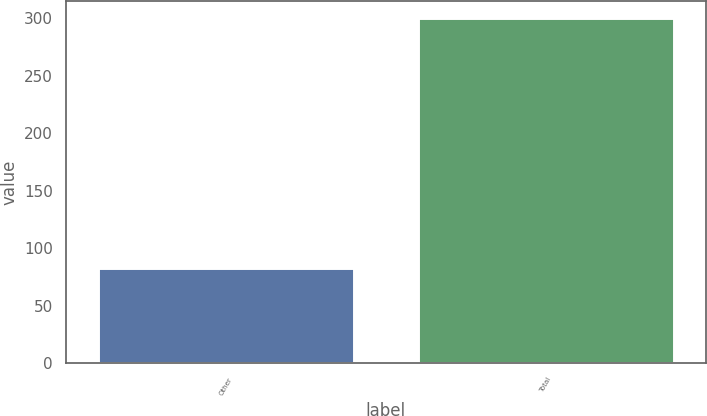Convert chart to OTSL. <chart><loc_0><loc_0><loc_500><loc_500><bar_chart><fcel>Other<fcel>Total<nl><fcel>83<fcel>300<nl></chart> 